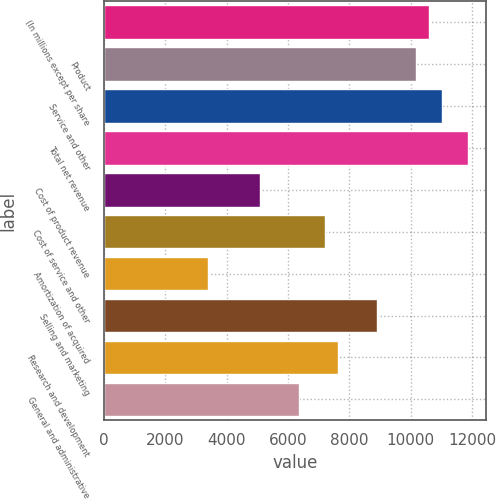Convert chart to OTSL. <chart><loc_0><loc_0><loc_500><loc_500><bar_chart><fcel>(In millions except per share<fcel>Product<fcel>Service and other<fcel>Total net revenue<fcel>Cost of product revenue<fcel>Cost of service and other<fcel>Amortization of acquired<fcel>Selling and marketing<fcel>Research and development<fcel>General and administrative<nl><fcel>10607.2<fcel>10182.9<fcel>11031.5<fcel>11880<fcel>5091.54<fcel>7212.94<fcel>3394.42<fcel>8910.06<fcel>7637.22<fcel>6364.38<nl></chart> 